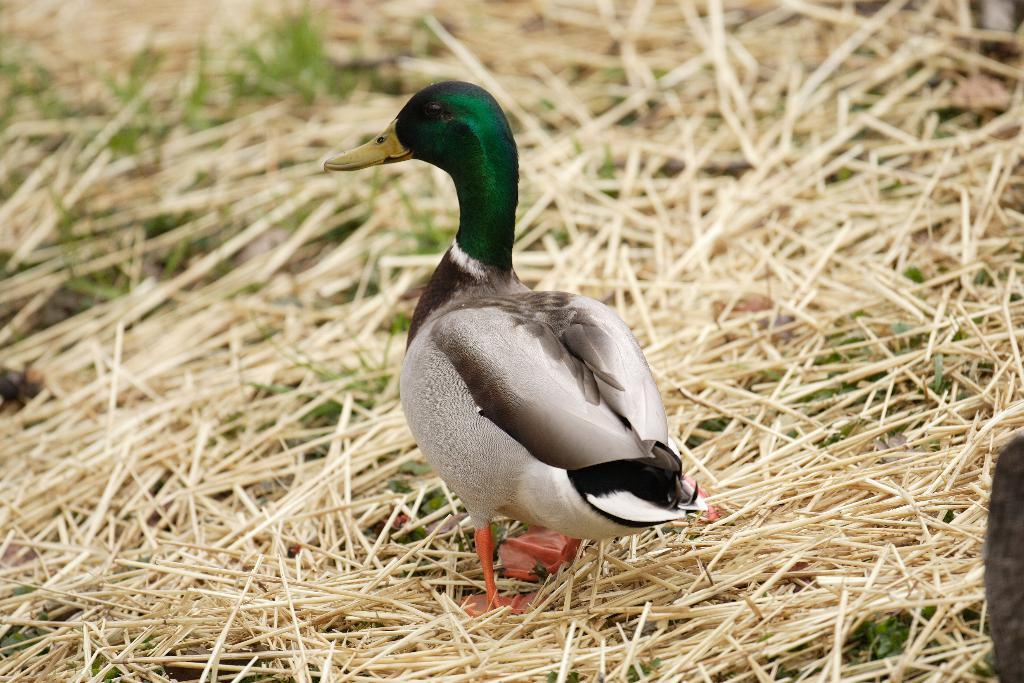What type of bird is in the center of the image? There is a mallard in the center of the image. What type of vegetation is in the background of the image? There is grass in the background of the image. Can you describe the condition of the grass in the background? The grass in the background is dry. How many members are on the team in the image? There is no team present in the image, only a mallard and grass. What type of knowledge is being displayed in the image? There is no knowledge being displayed in the image; it is a picture of a mallard and grass. 